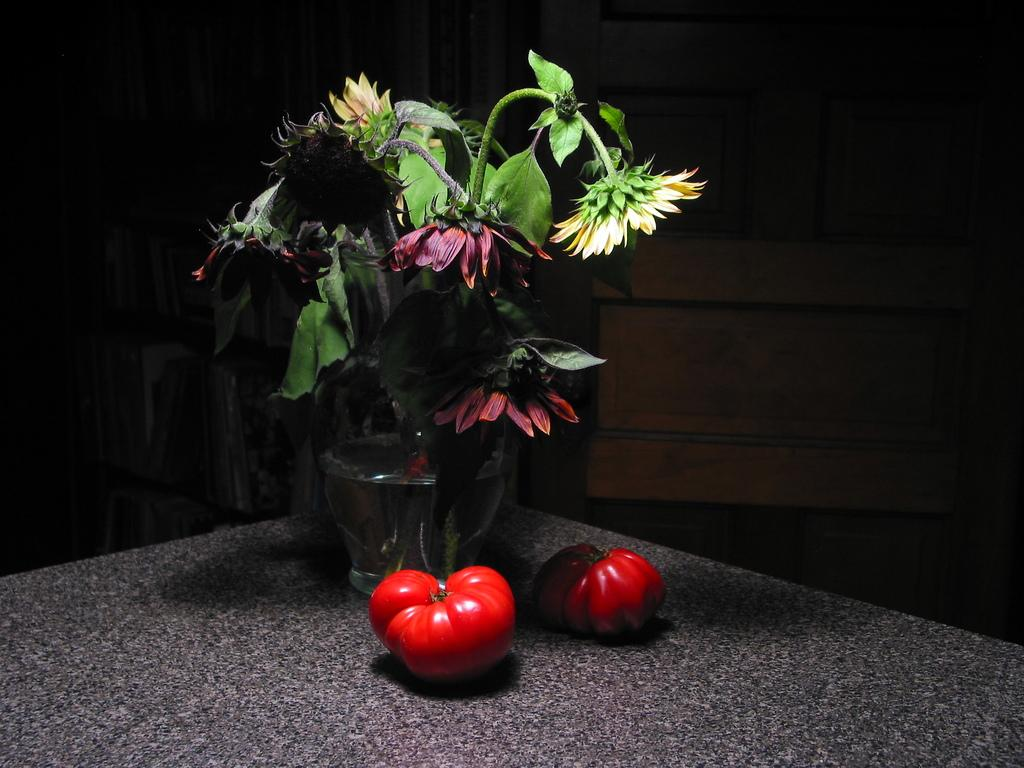What can be seen in the image that is typically used for holding flowers? There is a flower vase in the image. What type of food items are present on the table in the image? There are two vegetables on the table. What can be seen in the background of the image? There is a wall visible in the background of the image. What surface is visible beneath the objects in the image? There is a floor visible in the image. What type of metal is the actor using to stir the vegetables in the image? There is no actor or metal object present in the image, and the vegetables are not being stirred. 